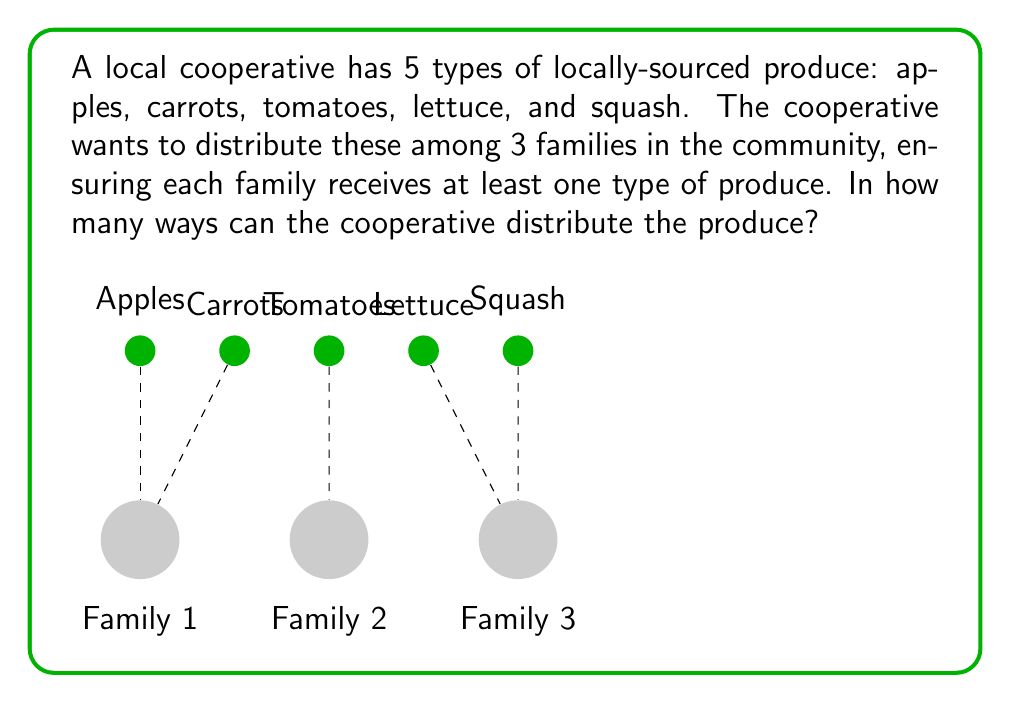Can you answer this question? Let's approach this step-by-step using the principle of inclusion-exclusion:

1) First, let's count the total number of ways to distribute 5 types of produce among 3 families without restrictions:
   $$3^5 = 243$$

2) However, we need to subtract the cases where at least one family doesn't receive any produce. Let's count these:

   a) Number of ways where at least one family gets nothing:
      $$\binom{3}{1} \cdot 2^5 = 3 \cdot 32 = 96$$

   b) Number of ways where at least two families get nothing:
      $$\binom{3}{2} \cdot 1^5 = 3 \cdot 1 = 3$$

   c) Number of ways where all three families get nothing:
      $$\binom{3}{3} \cdot 0^5 = 1 \cdot 0 = 0$$

3) Now, we apply the principle of inclusion-exclusion:
   $$\text{Answer} = 3^5 - \binom{3}{1} \cdot 2^5 + \binom{3}{2} \cdot 1^5 - \binom{3}{3} \cdot 0^5$$

4) Substituting the values:
   $$\text{Answer} = 243 - 96 + 3 - 0 = 150$$

Therefore, there are 150 ways to distribute the produce ensuring each family receives at least one type.
Answer: 150 